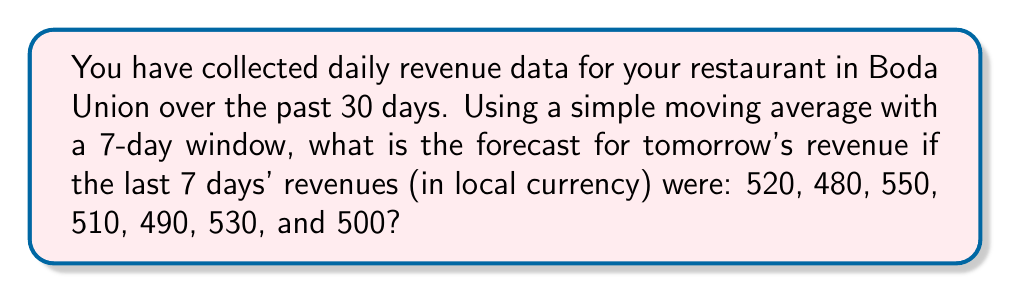Help me with this question. To forecast tomorrow's revenue using a simple moving average with a 7-day window, we need to follow these steps:

1. Identify the data points: We have the last 7 days' revenues:
   $$520, 480, 550, 510, 490, 530, 500$$

2. Calculate the sum of these 7 data points:
   $$520 + 480 + 550 + 510 + 490 + 530 + 500 = 3580$$

3. Divide the sum by the number of data points (7) to get the average:
   $$\frac{3580}{7} = 511.4285714$$

4. Round the result to a reasonable number of decimal places, in this case, to the nearest whole number since we're dealing with currency:
   $$511.4285714 \approx 511$$

Therefore, the forecast for tomorrow's revenue using a 7-day simple moving average is 511 in local currency.
Answer: 511 